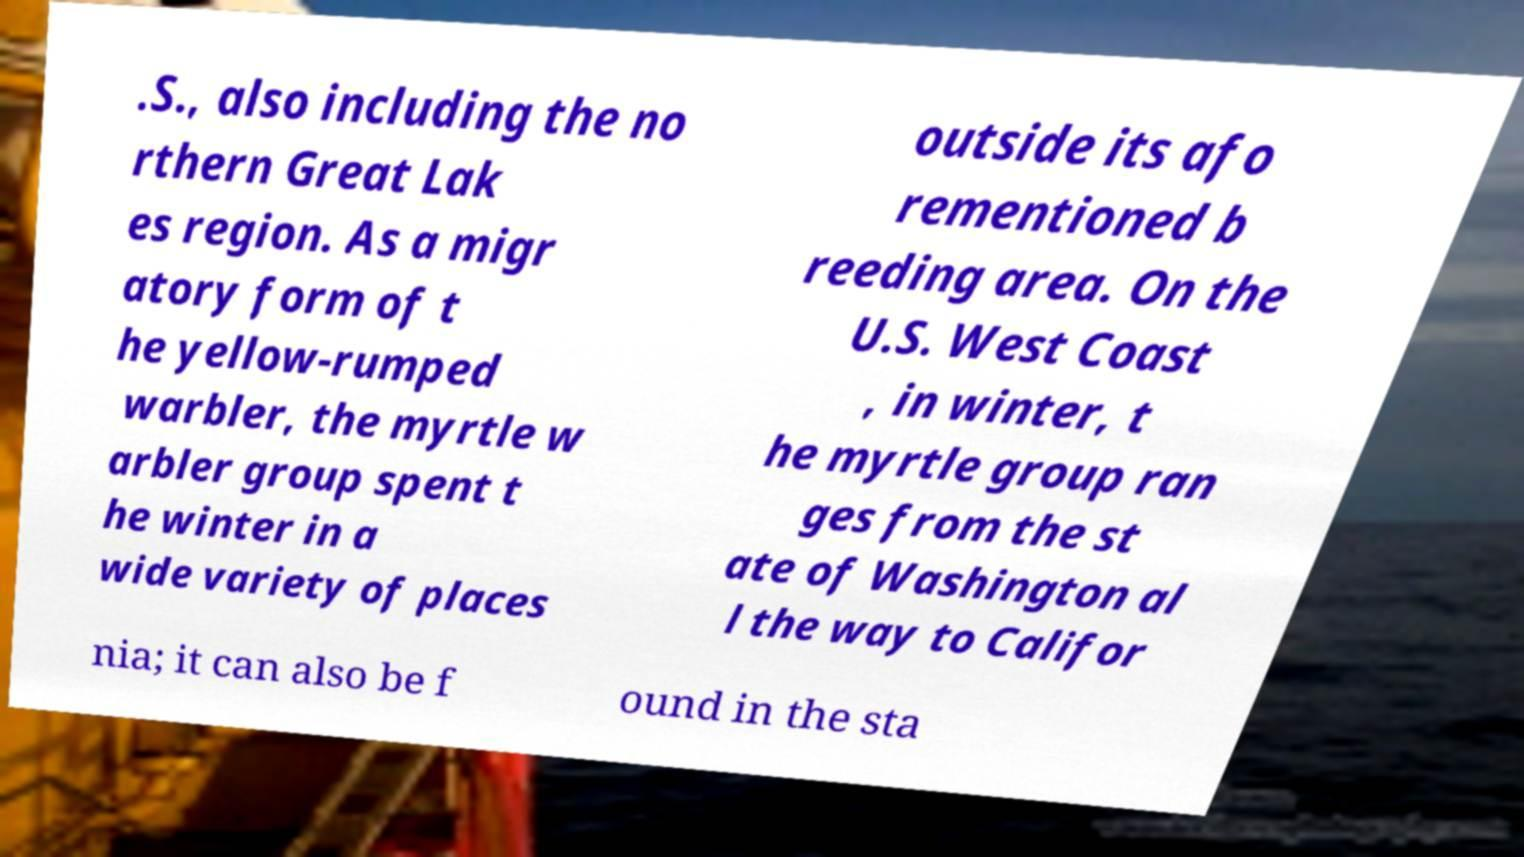Can you accurately transcribe the text from the provided image for me? .S., also including the no rthern Great Lak es region. As a migr atory form of t he yellow-rumped warbler, the myrtle w arbler group spent t he winter in a wide variety of places outside its afo rementioned b reeding area. On the U.S. West Coast , in winter, t he myrtle group ran ges from the st ate of Washington al l the way to Califor nia; it can also be f ound in the sta 